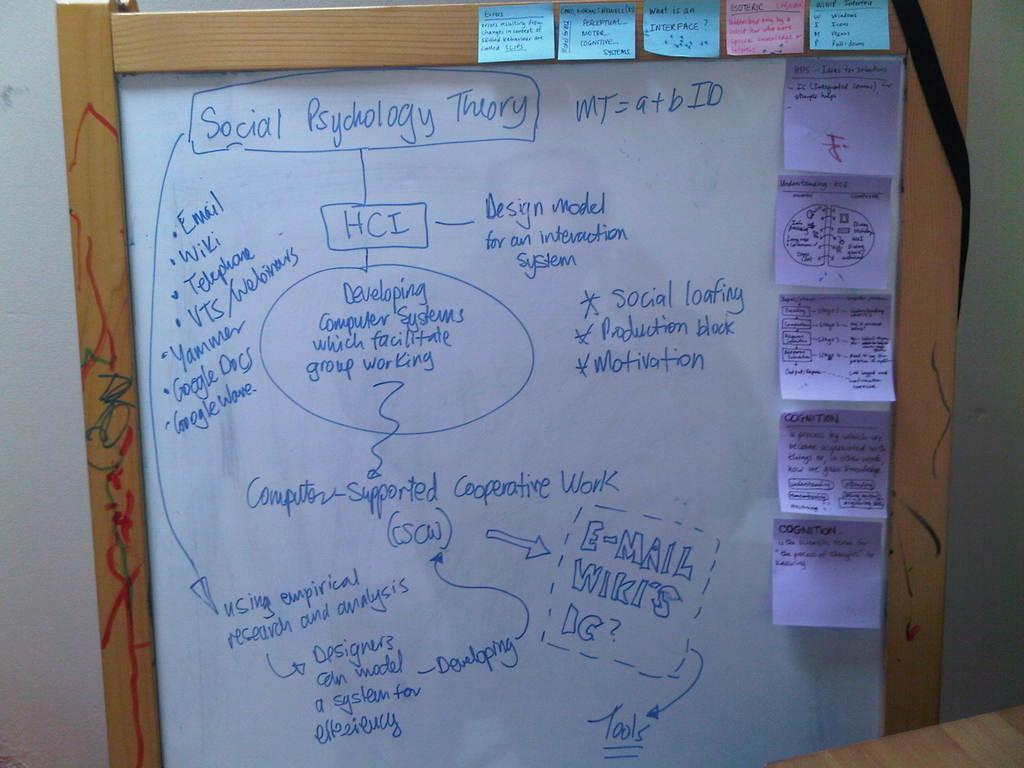<image>
Relay a brief, clear account of the picture shown. The white board talks about the Social Psychology Theory. 